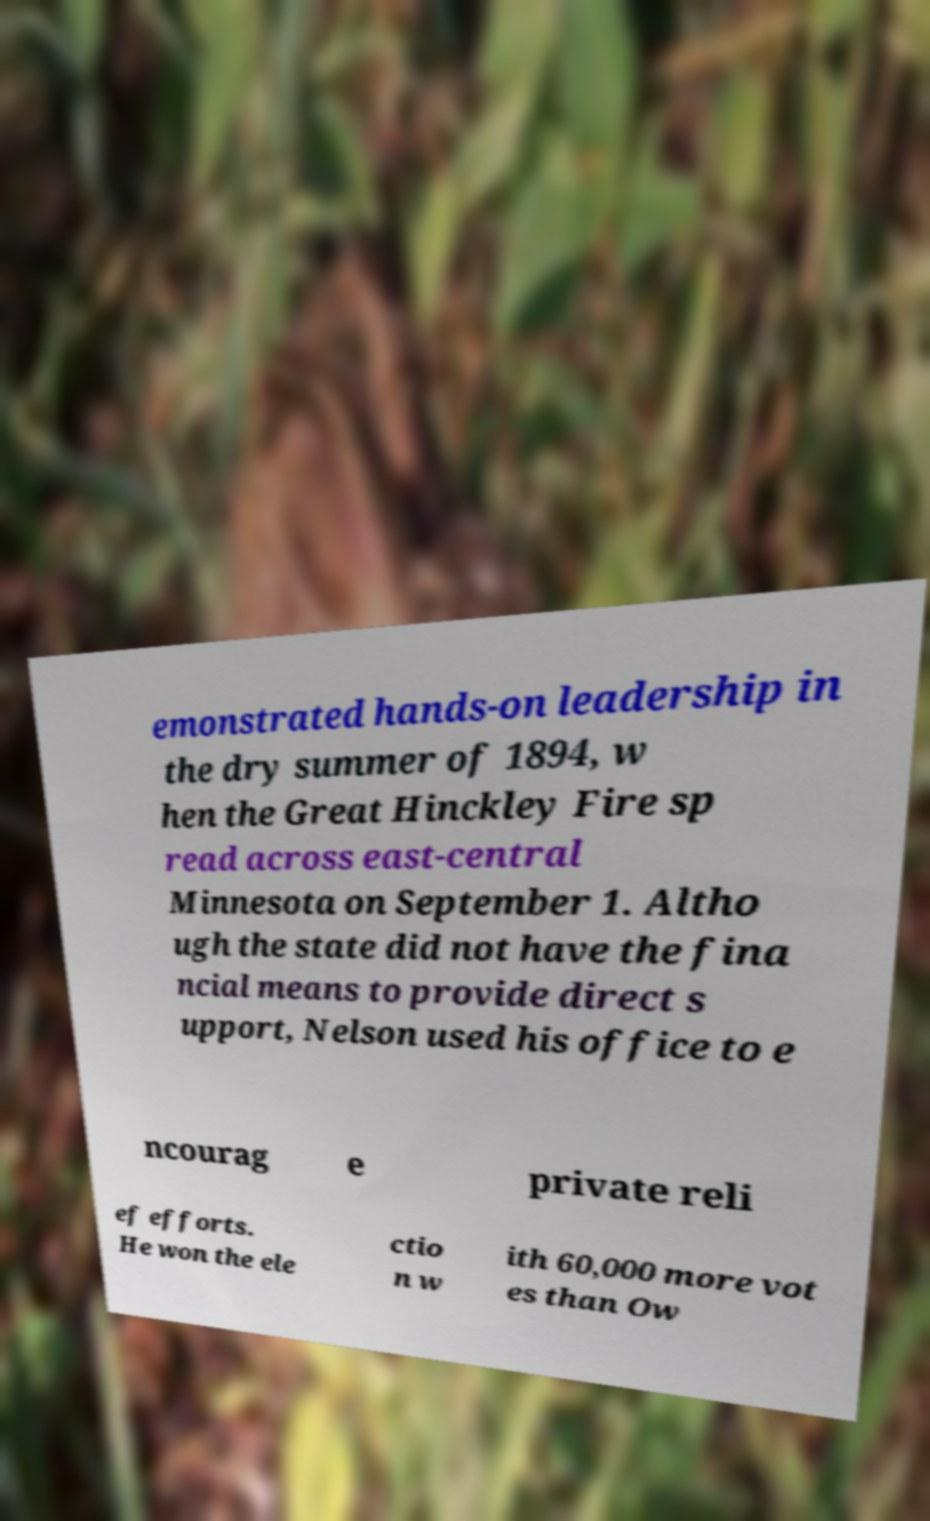I need the written content from this picture converted into text. Can you do that? emonstrated hands-on leadership in the dry summer of 1894, w hen the Great Hinckley Fire sp read across east-central Minnesota on September 1. Altho ugh the state did not have the fina ncial means to provide direct s upport, Nelson used his office to e ncourag e private reli ef efforts. He won the ele ctio n w ith 60,000 more vot es than Ow 